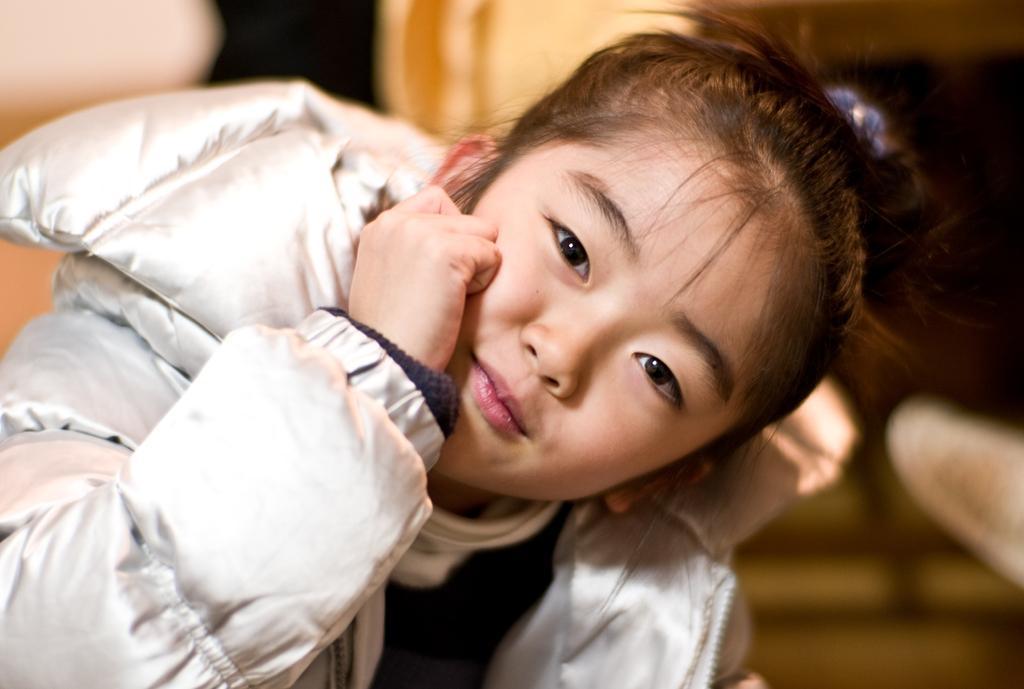Please provide a concise description of this image. In this image, we can see a girl wearing a white color jacket. In the background, we can see black color and cream color. 